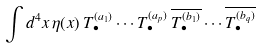Convert formula to latex. <formula><loc_0><loc_0><loc_500><loc_500>\int d ^ { 4 } x \, \eta ( x ) \, T _ { \bullet } ^ { ( a _ { 1 } ) } \cdots T _ { \bullet } ^ { ( a _ { p } ) } \, \overline { { { T _ { \bullet } ^ { ( b _ { 1 } ) } } } } \cdots \overline { { { T _ { \bullet } ^ { ( b _ { q } ) } } } }</formula> 